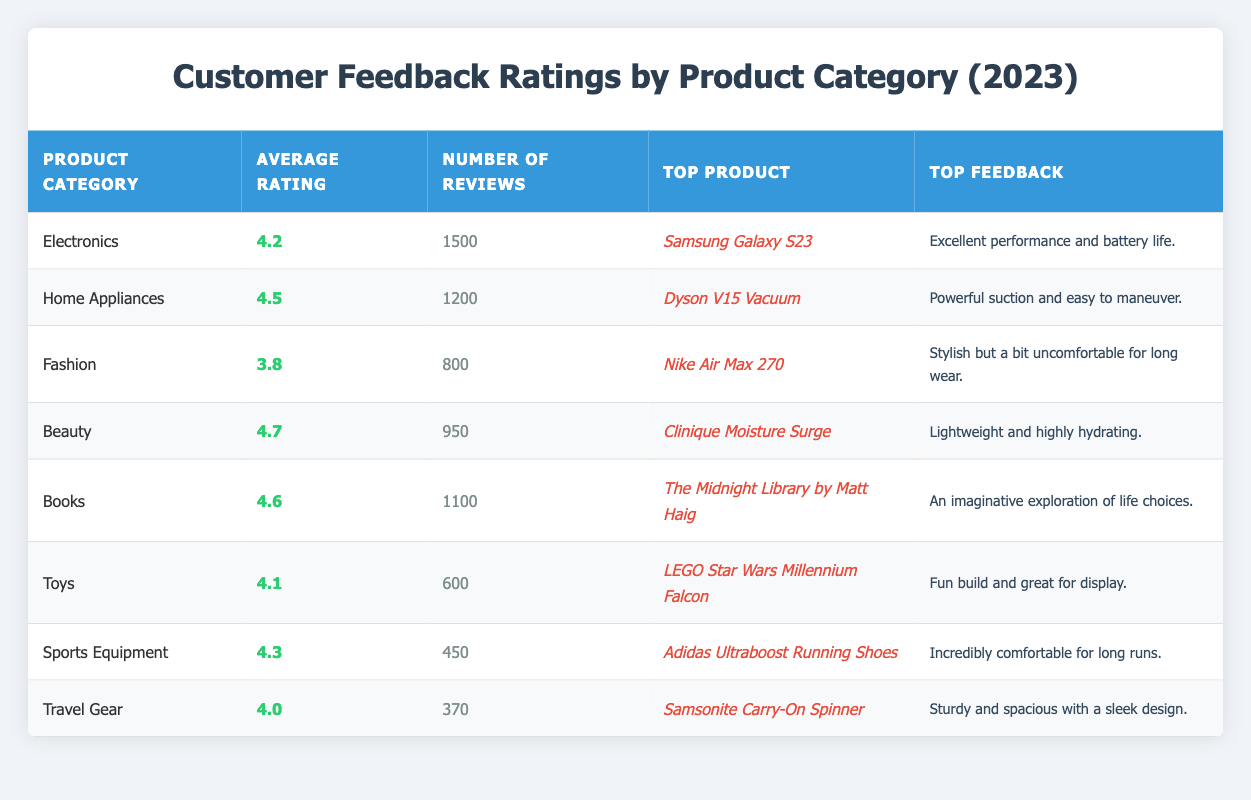What is the top-rated product in the Beauty category? In the table, the Beauty category shows an average rating of 4.7, and the top product listed is "Clinique Moisture Surge."
Answer: Clinique Moisture Surge How many reviews did the Home Appliances category receive? The table indicates that the Home Appliances category had a total of 1200 reviews listed under the "Number of Reviews" column.
Answer: 1200 Which product received the least average rating? The Fashion category has the least average rating of 3.8. Therefore, the product from that category, "Nike Air Max 270," is the one with the least rating.
Answer: Nike Air Max 270 How many more reviews does the Electronics category have compared to the Travel Gear category? The Electronics category has 1500 reviews, whereas the Travel Gear category has 370 reviews. The difference is 1500 - 370 = 1130.
Answer: 1130 Is the average rating of Sports Equipment higher than that of Travel Gear? The average rating of Sports Equipment is 4.3, and that of Travel Gear is 4.0. Since 4.3 is greater than 4.0, the statement is true.
Answer: Yes Which product category has the highest average rating? The Beauty category has the highest average rating at 4.7 when compared to the other categories listed in the table.
Answer: Beauty What is the total average rating for all categories combined? To find the total average rating, add all average ratings (4.2 + 4.5 + 3.8 + 4.7 + 4.6 + 4.1 + 4.3 + 4.0 = 34.2) and then divide by the number of categories (8). The total average rating is 34.2 / 8 = 4.275.
Answer: 4.275 How many reviews did the Toys category receive compared to the Beauty category? The Toys category received 600 reviews, while the Beauty category received 950 reviews. Therefore, the Beauty category has more reviews than Toys.
Answer: Beauty has more reviews Which category has a higher number of reviews: Books or Sports Equipment? The Books category has 1100 reviews while the Sports Equipment category has 450 reviews. Since 1100 is greater than 450, Books has more reviews.
Answer: Books If you sum the average ratings of the Electronics and Toys categories, what will be the result? The average ratings for Electronics and Toys are 4.2 and 4.1, respectively. Adding these ratings results in 4.2 + 4.1 = 8.3.
Answer: 8.3 